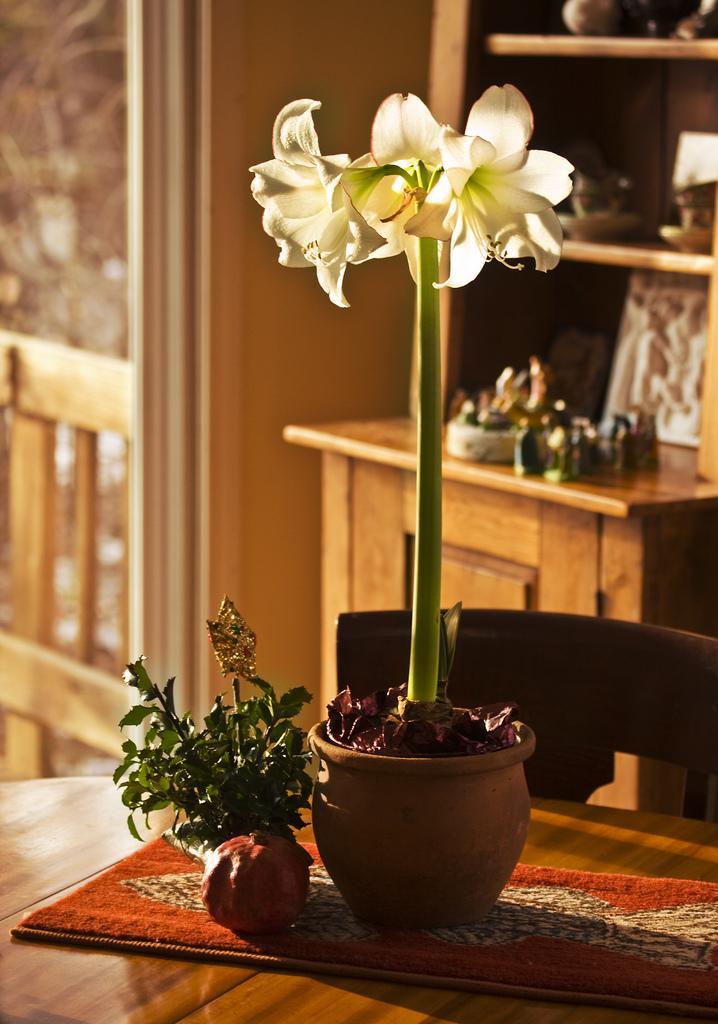Please provide a concise description of this image. In this image there is a flower pot in which there is a flower plant which is on the table. There is a chair in front of it. At the background there is a cupboard and shelves. 